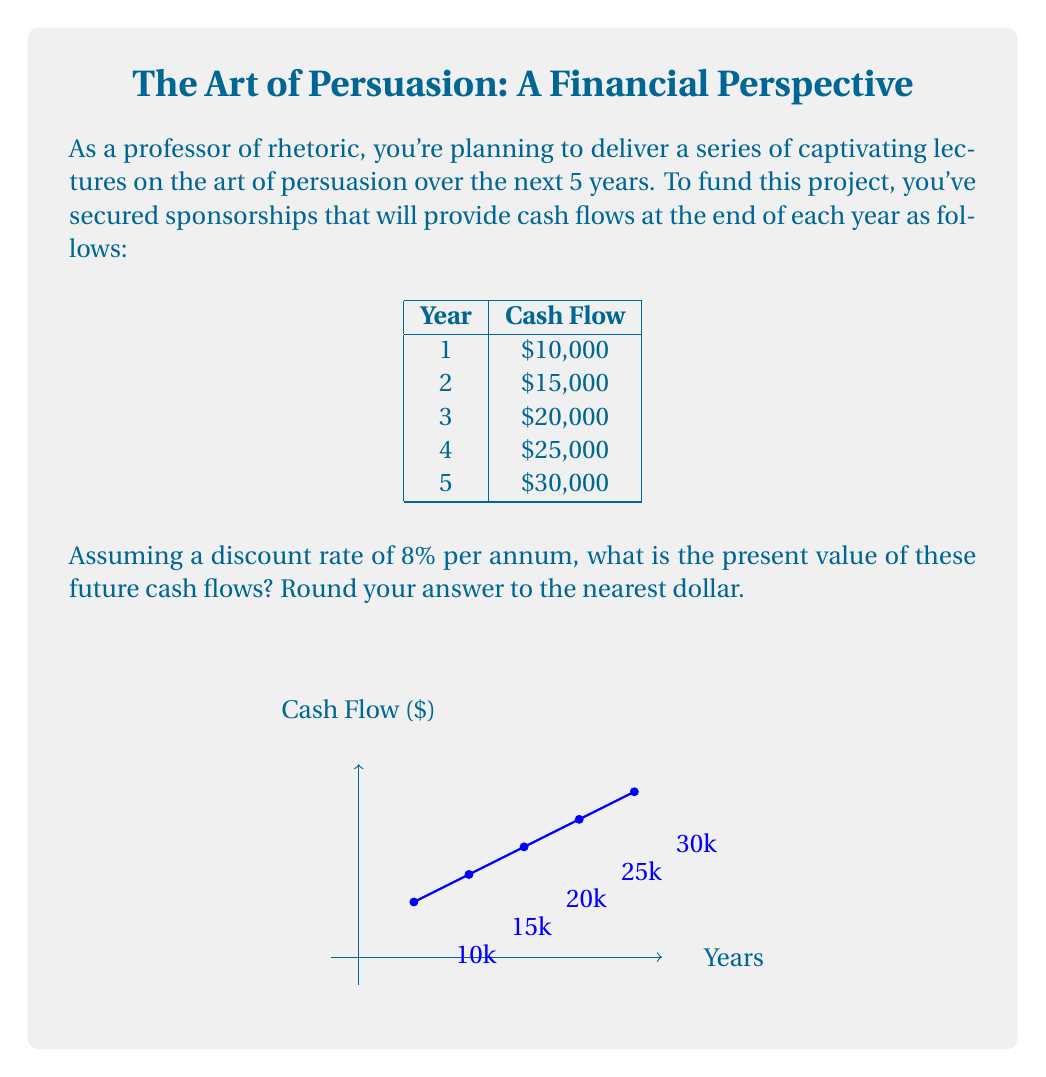Provide a solution to this math problem. To compute the present value of future cash flows, we need to discount each cash flow back to the present using the given discount rate. The formula for the present value (PV) of a single cash flow is:

$$ PV = \frac{CF_t}{(1 + r)^t} $$

Where $CF_t$ is the cash flow at time t, r is the discount rate, and t is the time period.

Let's calculate the PV for each year's cash flow:

Year 1: $PV_1 = \frac{10,000}{(1 + 0.08)^1} = \frac{10,000}{1.08} = 9,259.26$

Year 2: $PV_2 = \frac{15,000}{(1 + 0.08)^2} = \frac{15,000}{1.1664} = 12,859.91$

Year 3: $PV_3 = \frac{20,000}{(1 + 0.08)^3} = \frac{20,000}{1.2597} = 15,877.59$

Year 4: $PV_4 = \frac{25,000}{(1 + 0.08)^4} = \frac{25,000}{1.3605} = 18,375.60$

Year 5: $PV_5 = \frac{30,000}{(1 + 0.08)^5} = \frac{30,000}{1.4693} = 20,418.56$

Now, we sum up all these present values:

$$ Total PV = 9,259.26 + 12,859.91 + 15,877.59 + 18,375.60 + 20,418.56 = 76,790.92 $$

Rounding to the nearest dollar, we get $76,791.
Answer: $76,791 